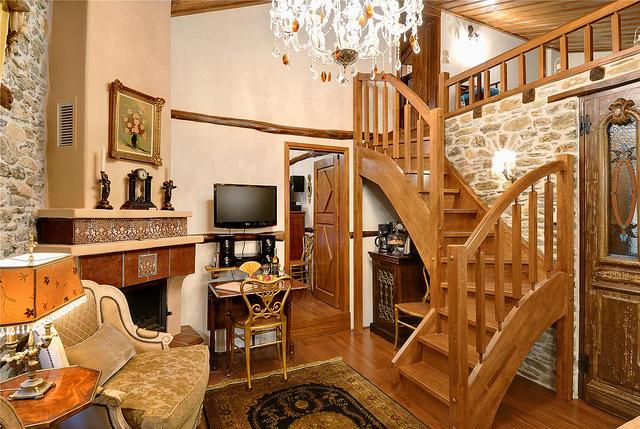What material is the staircase made of?
Write a very short answer. Wood. What is in the picture on the left wall?
Write a very short answer. Flowers. How many spindles are in the staircase?
Quick response, please. 11. 